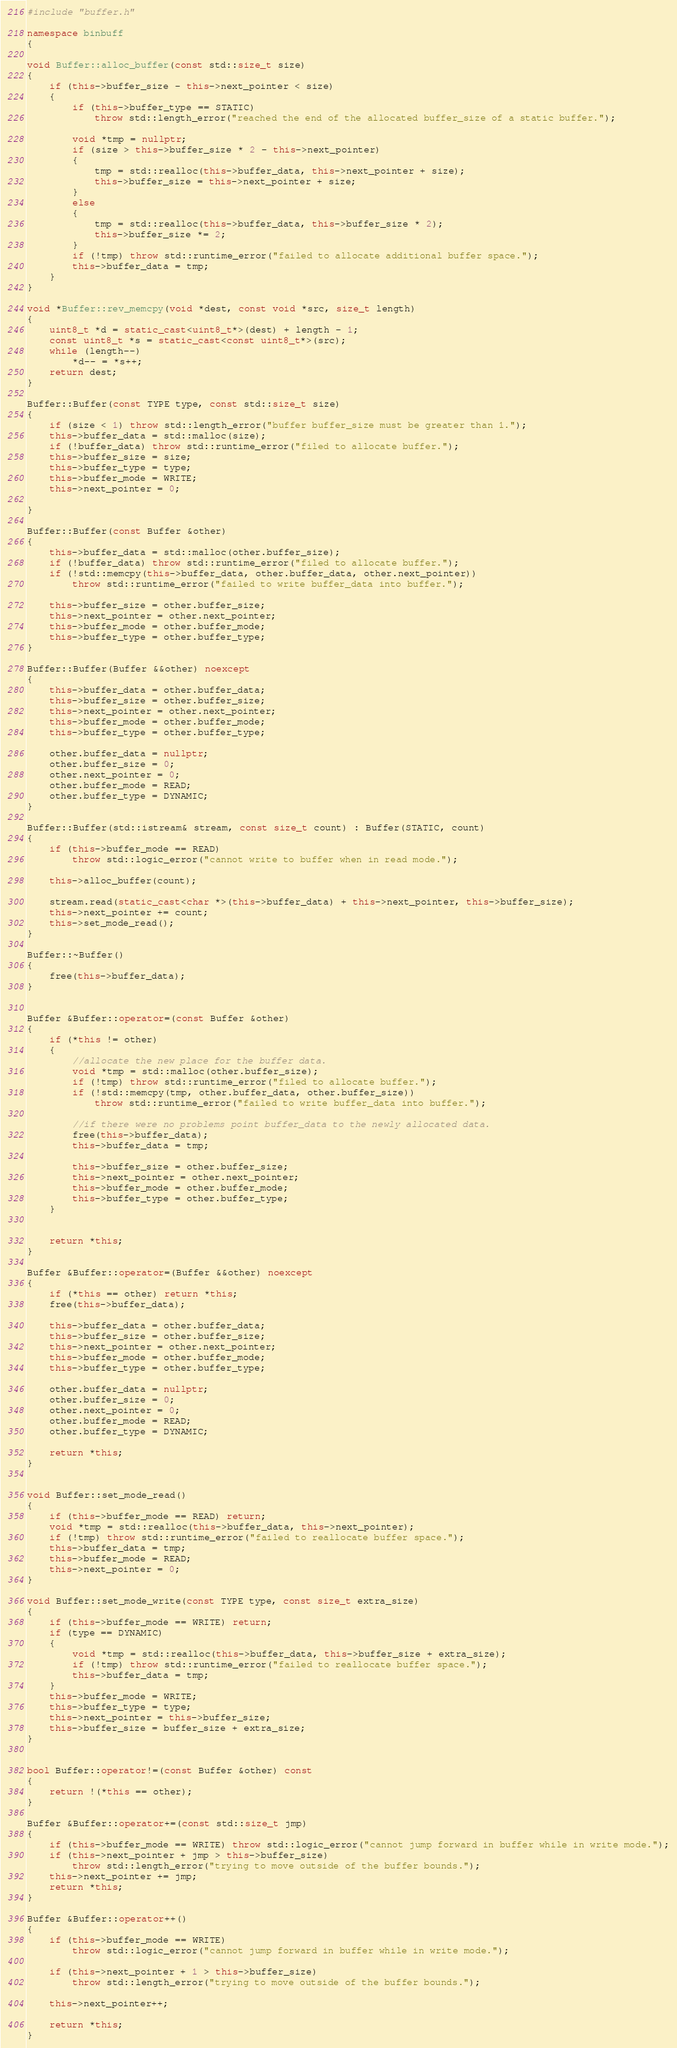<code> <loc_0><loc_0><loc_500><loc_500><_C++_>#include "buffer.h"

namespace binbuff
{

void Buffer::alloc_buffer(const std::size_t size)
{
	if (this->buffer_size - this->next_pointer < size)
	{
		if (this->buffer_type == STATIC)
			throw std::length_error("reached the end of the allocated buffer_size of a static buffer.");
		
		void *tmp = nullptr;
		if (size > this->buffer_size * 2 - this->next_pointer)
		{
			tmp = std::realloc(this->buffer_data, this->next_pointer + size);
			this->buffer_size = this->next_pointer + size;
		}
		else
		{
			tmp = std::realloc(this->buffer_data, this->buffer_size * 2);
			this->buffer_size *= 2;
		}
		if (!tmp) throw std::runtime_error("failed to allocate additional buffer space.");
		this->buffer_data = tmp;
	}
}

void *Buffer::rev_memcpy(void *dest, const void *src, size_t length)
{
	uint8_t *d = static_cast<uint8_t*>(dest) + length - 1;
	const uint8_t *s = static_cast<const uint8_t*>(src);
	while (length--)
		*d-- = *s++;
	return dest;
}

Buffer::Buffer(const TYPE type, const std::size_t size)
{
	if (size < 1) throw std::length_error("buffer buffer_size must be greater than 1.");
	this->buffer_data = std::malloc(size);
	if (!buffer_data) throw std::runtime_error("filed to allocate buffer.");
	this->buffer_size = size;
	this->buffer_type = type;
	this->buffer_mode = WRITE;
	this->next_pointer = 0;

}

Buffer::Buffer(const Buffer &other)
{
	this->buffer_data = std::malloc(other.buffer_size);
	if (!buffer_data) throw std::runtime_error("filed to allocate buffer.");
	if (!std::memcpy(this->buffer_data, other.buffer_data, other.next_pointer))
		throw std::runtime_error("failed to write buffer_data into buffer.");

	this->buffer_size = other.buffer_size;
	this->next_pointer = other.next_pointer;
	this->buffer_mode = other.buffer_mode;
	this->buffer_type = other.buffer_type;
}

Buffer::Buffer(Buffer &&other) noexcept
{
	this->buffer_data = other.buffer_data;
	this->buffer_size = other.buffer_size;
	this->next_pointer = other.next_pointer;
	this->buffer_mode = other.buffer_mode;
	this->buffer_type = other.buffer_type;

	other.buffer_data = nullptr;
	other.buffer_size = 0;
	other.next_pointer = 0;
	other.buffer_mode = READ;
	other.buffer_type = DYNAMIC;
}

Buffer::Buffer(std::istream& stream, const size_t count) : Buffer(STATIC, count)
{
	if (this->buffer_mode == READ)
		throw std::logic_error("cannot write to buffer when in read mode.");

	this->alloc_buffer(count);

	stream.read(static_cast<char *>(this->buffer_data) + this->next_pointer, this->buffer_size);
	this->next_pointer += count;
	this->set_mode_read();
}

Buffer::~Buffer()
{
	free(this->buffer_data);
}


Buffer &Buffer::operator=(const Buffer &other)
{
	if (*this != other)
	{
		//allocate the new place for the buffer data.
		void *tmp = std::malloc(other.buffer_size);
		if (!tmp) throw std::runtime_error("filed to allocate buffer.");
		if (!std::memcpy(tmp, other.buffer_data, other.buffer_size))
			throw std::runtime_error("failed to write buffer_data into buffer.");

		//if there were no problems point buffer_data to the newly allocated data.
		free(this->buffer_data);
		this->buffer_data = tmp;

		this->buffer_size = other.buffer_size;
		this->next_pointer = other.next_pointer;
		this->buffer_mode = other.buffer_mode;
		this->buffer_type = other.buffer_type;
	}


	return *this;
}

Buffer &Buffer::operator=(Buffer &&other) noexcept
{
	if (*this == other) return *this;
	free(this->buffer_data);

	this->buffer_data = other.buffer_data;
	this->buffer_size = other.buffer_size;
	this->next_pointer = other.next_pointer;
	this->buffer_mode = other.buffer_mode;
	this->buffer_type = other.buffer_type;

	other.buffer_data = nullptr;
	other.buffer_size = 0;
	other.next_pointer = 0;
	other.buffer_mode = READ;
	other.buffer_type = DYNAMIC;

	return *this;
}


void Buffer::set_mode_read()
{
	if (this->buffer_mode == READ) return;
	void *tmp = std::realloc(this->buffer_data, this->next_pointer);
	if (!tmp) throw std::runtime_error("failed to reallocate buffer space.");
	this->buffer_data = tmp;
	this->buffer_mode = READ;
	this->next_pointer = 0;
}

void Buffer::set_mode_write(const TYPE type, const size_t extra_size)
{
	if (this->buffer_mode == WRITE) return;
	if (type == DYNAMIC)
	{
		void *tmp = std::realloc(this->buffer_data, this->buffer_size + extra_size);
		if (!tmp) throw std::runtime_error("failed to reallocate buffer space.");
		this->buffer_data = tmp;
	}
	this->buffer_mode = WRITE;
	this->buffer_type = type;
	this->next_pointer = this->buffer_size;
	this->buffer_size = buffer_size + extra_size;
}


bool Buffer::operator!=(const Buffer &other) const
{
	return !(*this == other);
}

Buffer &Buffer::operator+=(const std::size_t jmp)
{
	if (this->buffer_mode == WRITE) throw std::logic_error("cannot jump forward in buffer while in write mode.");
	if (this->next_pointer + jmp > this->buffer_size)
		throw std::length_error("trying to move outside of the buffer bounds.");
	this->next_pointer += jmp;
	return *this;
}

Buffer &Buffer::operator++()
{
	if (this->buffer_mode == WRITE)
		throw std::logic_error("cannot jump forward in buffer while in write mode.");

	if (this->next_pointer + 1 > this->buffer_size)
		throw std::length_error("trying to move outside of the buffer bounds.");

	this->next_pointer++;

	return *this;
}
</code> 